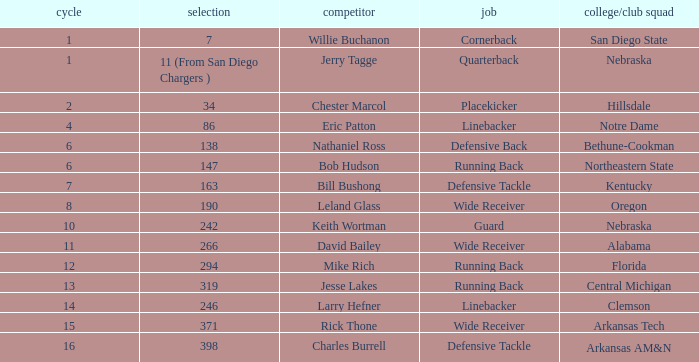Could you parse the entire table as a dict? {'header': ['cycle', 'selection', 'competitor', 'job', 'college/club squad'], 'rows': [['1', '7', 'Willie Buchanon', 'Cornerback', 'San Diego State'], ['1', '11 (From San Diego Chargers )', 'Jerry Tagge', 'Quarterback', 'Nebraska'], ['2', '34', 'Chester Marcol', 'Placekicker', 'Hillsdale'], ['4', '86', 'Eric Patton', 'Linebacker', 'Notre Dame'], ['6', '138', 'Nathaniel Ross', 'Defensive Back', 'Bethune-Cookman'], ['6', '147', 'Bob Hudson', 'Running Back', 'Northeastern State'], ['7', '163', 'Bill Bushong', 'Defensive Tackle', 'Kentucky'], ['8', '190', 'Leland Glass', 'Wide Receiver', 'Oregon'], ['10', '242', 'Keith Wortman', 'Guard', 'Nebraska'], ['11', '266', 'David Bailey', 'Wide Receiver', 'Alabama'], ['12', '294', 'Mike Rich', 'Running Back', 'Florida'], ['13', '319', 'Jesse Lakes', 'Running Back', 'Central Michigan'], ['14', '246', 'Larry Hefner', 'Linebacker', 'Clemson'], ['15', '371', 'Rick Thone', 'Wide Receiver', 'Arkansas Tech'], ['16', '398', 'Charles Burrell', 'Defensive Tackle', 'Arkansas AM&N']]} In which round does the position of cornerback occur? 1.0. 